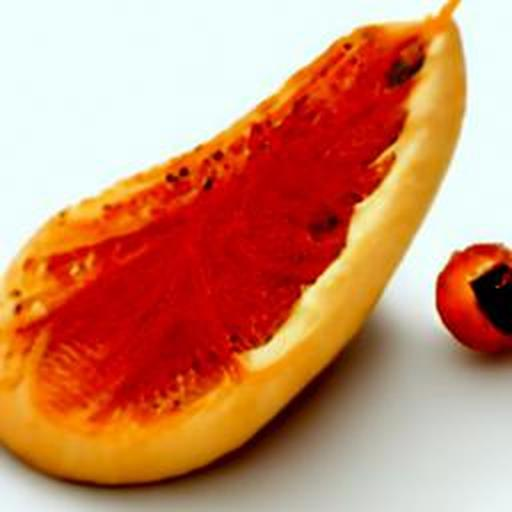Are there different varieties of papaya? If so, how do they differ? Yes, there are several varieties of papaya. The two most common types are the smaller, sweeter Hawaiian variety, often called 'Solo', and the larger Mexican papaya, which has a milder sweetness. Their skin color, flesh texture, and taste can vary significantly depending on the type. 